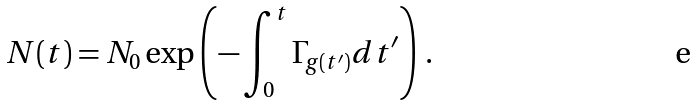Convert formula to latex. <formula><loc_0><loc_0><loc_500><loc_500>N ( t ) = N _ { 0 } \exp \left ( - \int _ { 0 } ^ { t } \Gamma _ { g ( t ^ { \prime } ) } d t ^ { \prime } \right ) \, .</formula> 